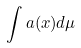Convert formula to latex. <formula><loc_0><loc_0><loc_500><loc_500>\int a ( x ) d \mu</formula> 